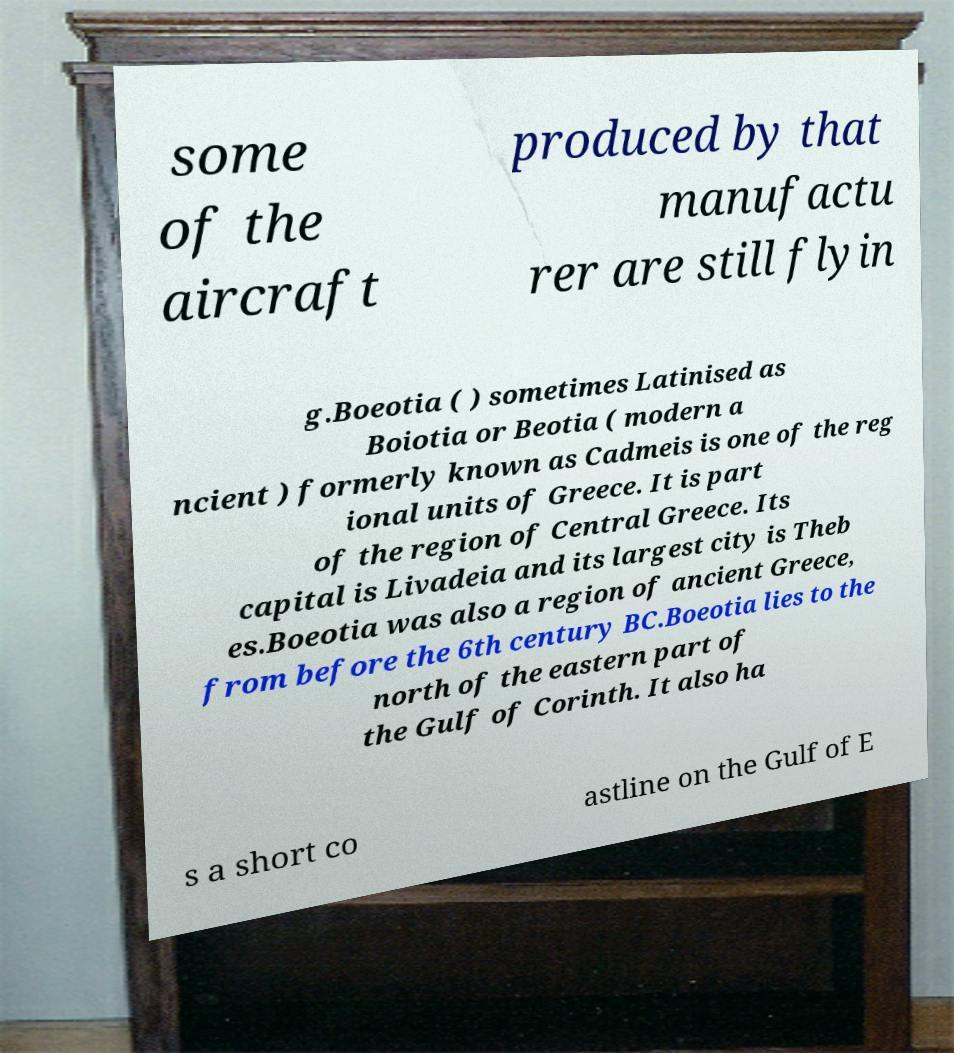Can you accurately transcribe the text from the provided image for me? some of the aircraft produced by that manufactu rer are still flyin g.Boeotia ( ) sometimes Latinised as Boiotia or Beotia ( modern a ncient ) formerly known as Cadmeis is one of the reg ional units of Greece. It is part of the region of Central Greece. Its capital is Livadeia and its largest city is Theb es.Boeotia was also a region of ancient Greece, from before the 6th century BC.Boeotia lies to the north of the eastern part of the Gulf of Corinth. It also ha s a short co astline on the Gulf of E 